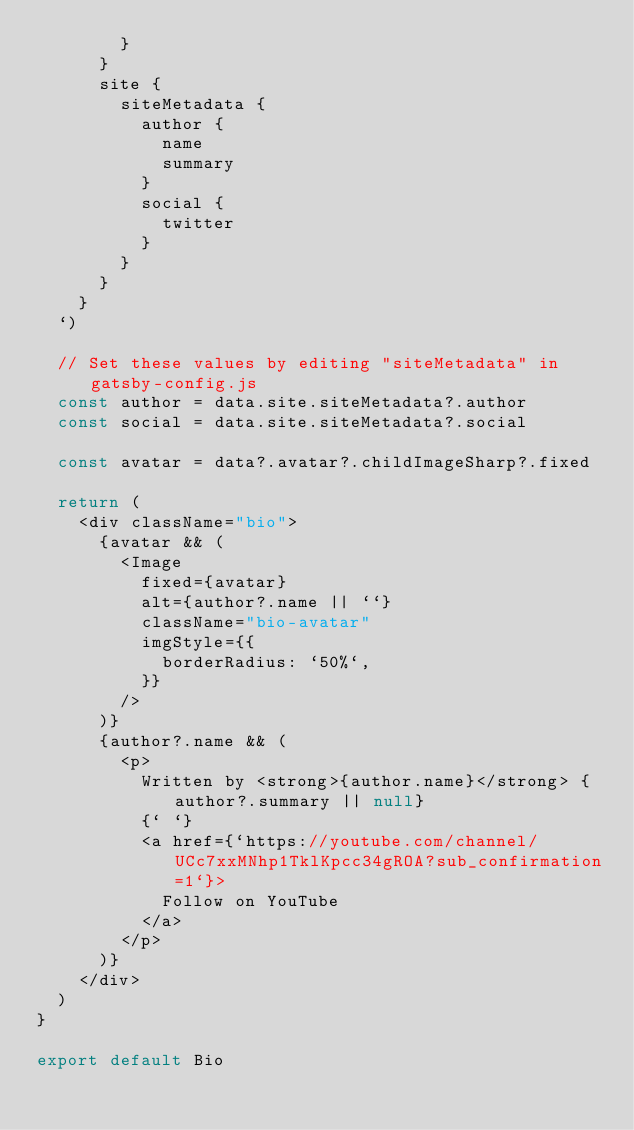<code> <loc_0><loc_0><loc_500><loc_500><_JavaScript_>        }
      }
      site {
        siteMetadata {
          author {
            name
            summary
          }
          social {
            twitter
          }
        }
      }
    }
  `)

  // Set these values by editing "siteMetadata" in gatsby-config.js
  const author = data.site.siteMetadata?.author
  const social = data.site.siteMetadata?.social

  const avatar = data?.avatar?.childImageSharp?.fixed

  return (
    <div className="bio">
      {avatar && (
        <Image
          fixed={avatar}
          alt={author?.name || ``}
          className="bio-avatar"
          imgStyle={{
            borderRadius: `50%`,
          }}
        />
      )}
      {author?.name && (
        <p>
          Written by <strong>{author.name}</strong> {author?.summary || null}
          {` `}
          <a href={`https://youtube.com/channel/UCc7xxMNhp1TklKpcc34gROA?sub_confirmation=1`}>
            Follow on YouTube
          </a>
        </p>
      )}
    </div>
  )
}

export default Bio
</code> 